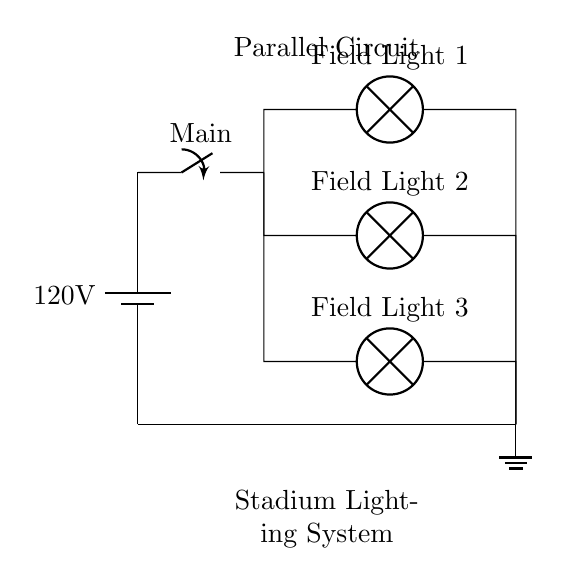What is the voltage of this circuit? The voltage is 120 volts, which is indicated by the battery symbol at the left side of the circuit diagram.
Answer: 120 volts How many field lights are connected in parallel? There are three field lights shown in the circuit, each connected to the parallel branches. You can identify them as Field Light 1, Field Light 2, and Field Light 3.
Answer: Three What would happen to the other lights if one light fails? If one light fails, the other two would remain lit because they are connected in parallel. This means each light operates independently and maintains the circuit’s overall functionality.
Answer: The other lights remain lit What is the main function of the switch in this circuit? The switch serves as a controller for the power supply, allowing or cutting off the current flow to the entire lighting system.
Answer: Power control What happens to the current through each lamp? The current splits across the parallel branches, allowing each lamp to receive the full voltage of the source, but the total current is the sum of the currents through each individual lamp.
Answer: Current splits What is the ground connection used for in this circuit? The ground connection provides a reference point for the voltage in the circuit and ensures safety by directing excess current away in case of a fault.
Answer: Safety reference 